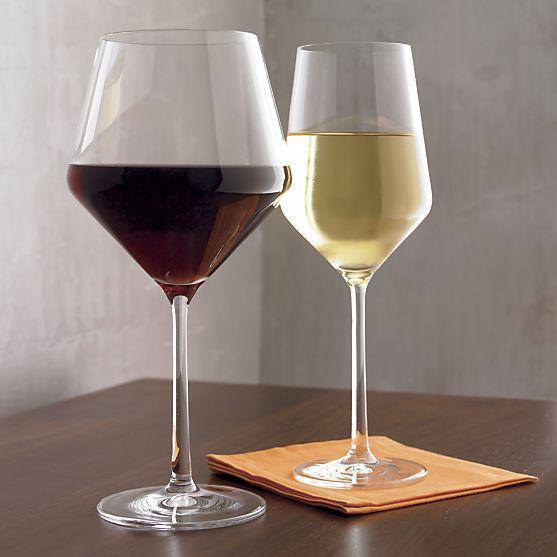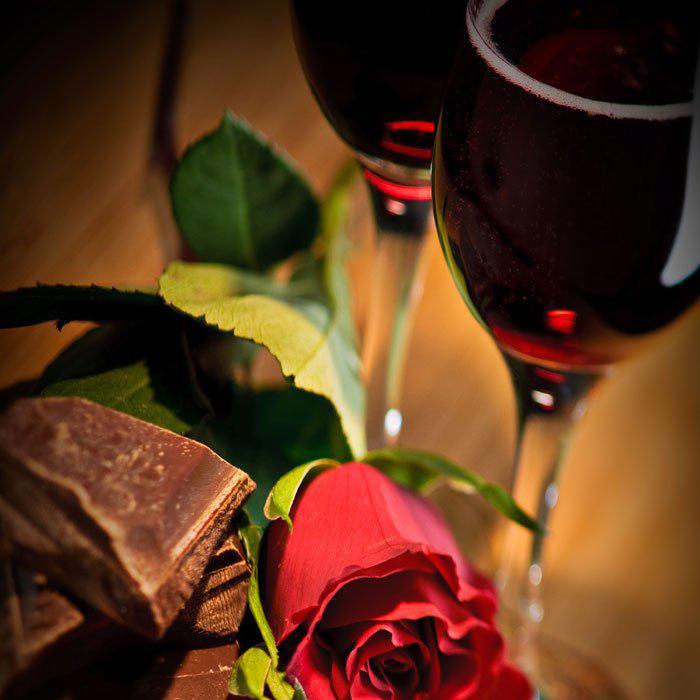The first image is the image on the left, the second image is the image on the right. For the images shown, is this caption "There are two glasses in each of the images." true? Answer yes or no. Yes. The first image is the image on the left, the second image is the image on the right. For the images shown, is this caption "The left image contains two glasses of wine." true? Answer yes or no. Yes. 